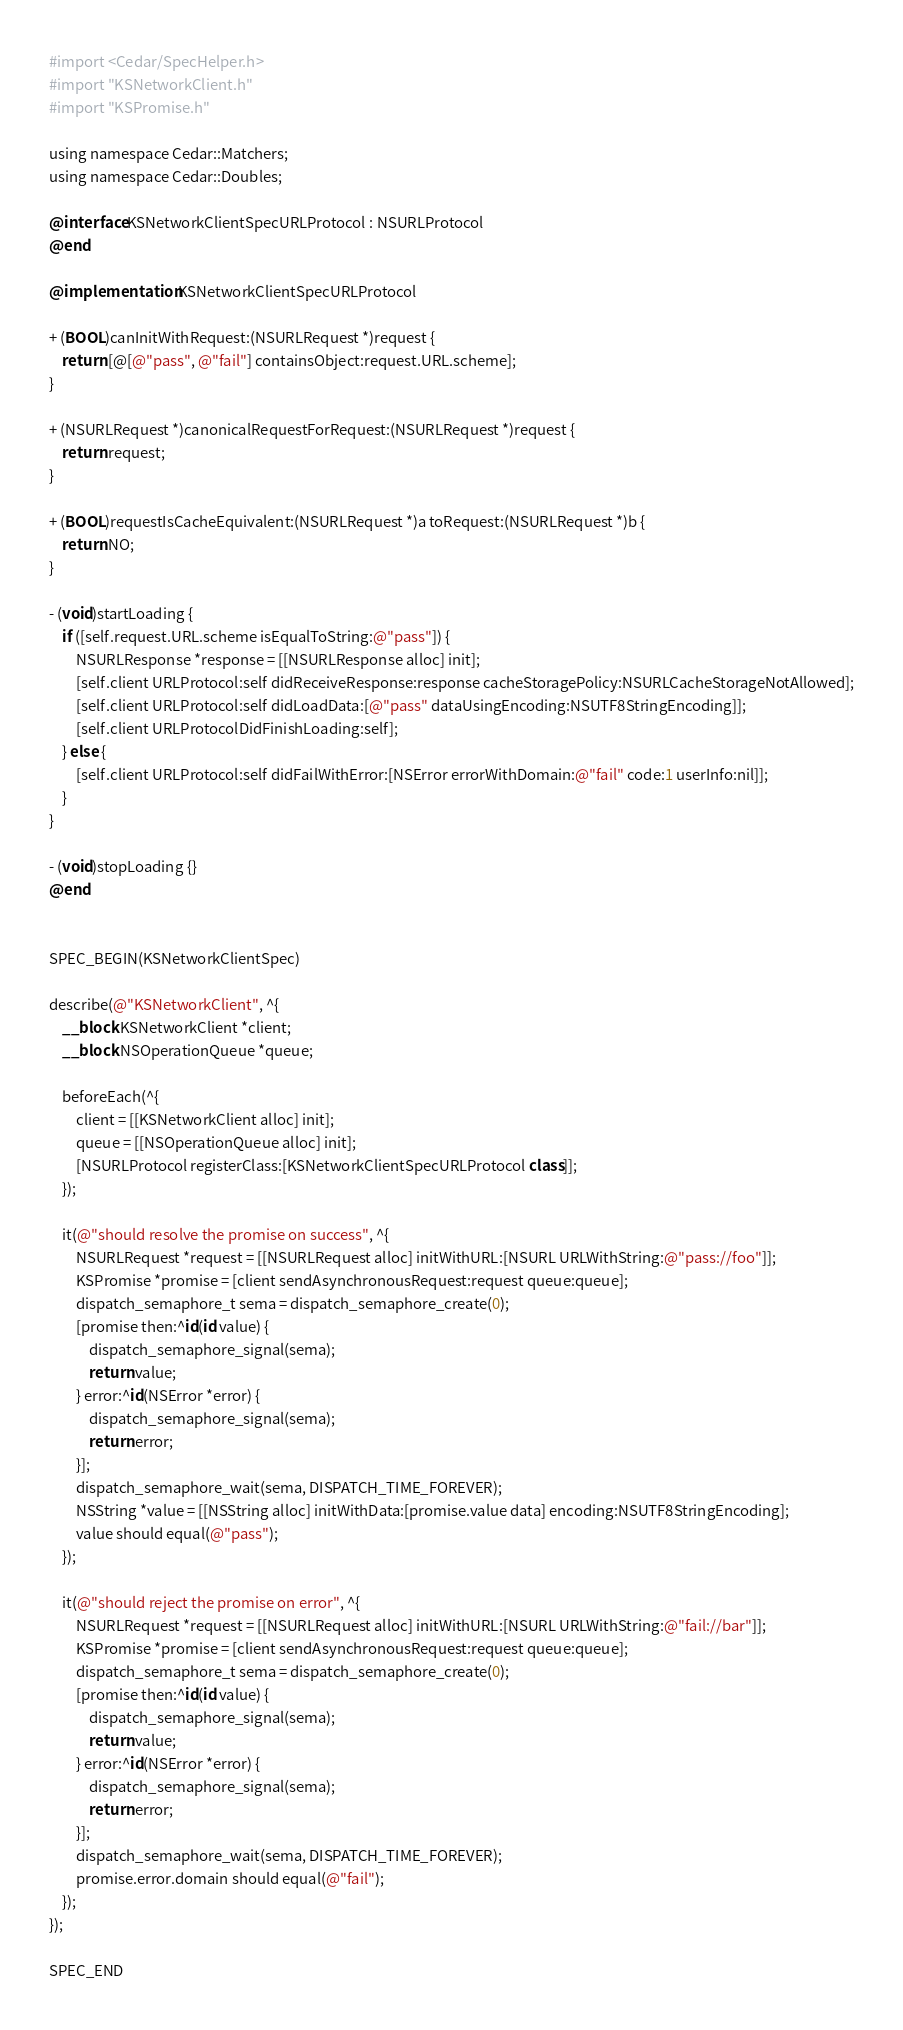<code> <loc_0><loc_0><loc_500><loc_500><_ObjectiveC_>#import <Cedar/SpecHelper.h>
#import "KSNetworkClient.h"
#import "KSPromise.h"

using namespace Cedar::Matchers;
using namespace Cedar::Doubles;

@interface KSNetworkClientSpecURLProtocol : NSURLProtocol
@end

@implementation KSNetworkClientSpecURLProtocol

+ (BOOL)canInitWithRequest:(NSURLRequest *)request {
    return [@[@"pass", @"fail"] containsObject:request.URL.scheme];
}

+ (NSURLRequest *)canonicalRequestForRequest:(NSURLRequest *)request {
    return request;
}

+ (BOOL)requestIsCacheEquivalent:(NSURLRequest *)a toRequest:(NSURLRequest *)b {
    return NO;
}

- (void)startLoading {
    if ([self.request.URL.scheme isEqualToString:@"pass"]) {
        NSURLResponse *response = [[NSURLResponse alloc] init];
        [self.client URLProtocol:self didReceiveResponse:response cacheStoragePolicy:NSURLCacheStorageNotAllowed];
        [self.client URLProtocol:self didLoadData:[@"pass" dataUsingEncoding:NSUTF8StringEncoding]];
        [self.client URLProtocolDidFinishLoading:self];
    } else {
        [self.client URLProtocol:self didFailWithError:[NSError errorWithDomain:@"fail" code:1 userInfo:nil]];
    }
}

- (void)stopLoading {}
@end


SPEC_BEGIN(KSNetworkClientSpec)

describe(@"KSNetworkClient", ^{
    __block KSNetworkClient *client;
    __block NSOperationQueue *queue;

    beforeEach(^{
        client = [[KSNetworkClient alloc] init];
        queue = [[NSOperationQueue alloc] init];
        [NSURLProtocol registerClass:[KSNetworkClientSpecURLProtocol class]];
    });

    it(@"should resolve the promise on success", ^{
        NSURLRequest *request = [[NSURLRequest alloc] initWithURL:[NSURL URLWithString:@"pass://foo"]];
        KSPromise *promise = [client sendAsynchronousRequest:request queue:queue];
        dispatch_semaphore_t sema = dispatch_semaphore_create(0);
        [promise then:^id(id value) {
            dispatch_semaphore_signal(sema);
            return value;
        } error:^id(NSError *error) {
            dispatch_semaphore_signal(sema);
            return error;
        }];
        dispatch_semaphore_wait(sema, DISPATCH_TIME_FOREVER);
        NSString *value = [[NSString alloc] initWithData:[promise.value data] encoding:NSUTF8StringEncoding];
        value should equal(@"pass");
    });

    it(@"should reject the promise on error", ^{
        NSURLRequest *request = [[NSURLRequest alloc] initWithURL:[NSURL URLWithString:@"fail://bar"]];
        KSPromise *promise = [client sendAsynchronousRequest:request queue:queue];
        dispatch_semaphore_t sema = dispatch_semaphore_create(0);
        [promise then:^id(id value) {
            dispatch_semaphore_signal(sema);
            return value;
        } error:^id(NSError *error) {
            dispatch_semaphore_signal(sema);
            return error;
        }];
        dispatch_semaphore_wait(sema, DISPATCH_TIME_FOREVER);
        promise.error.domain should equal(@"fail");
    });
});

SPEC_END
</code> 